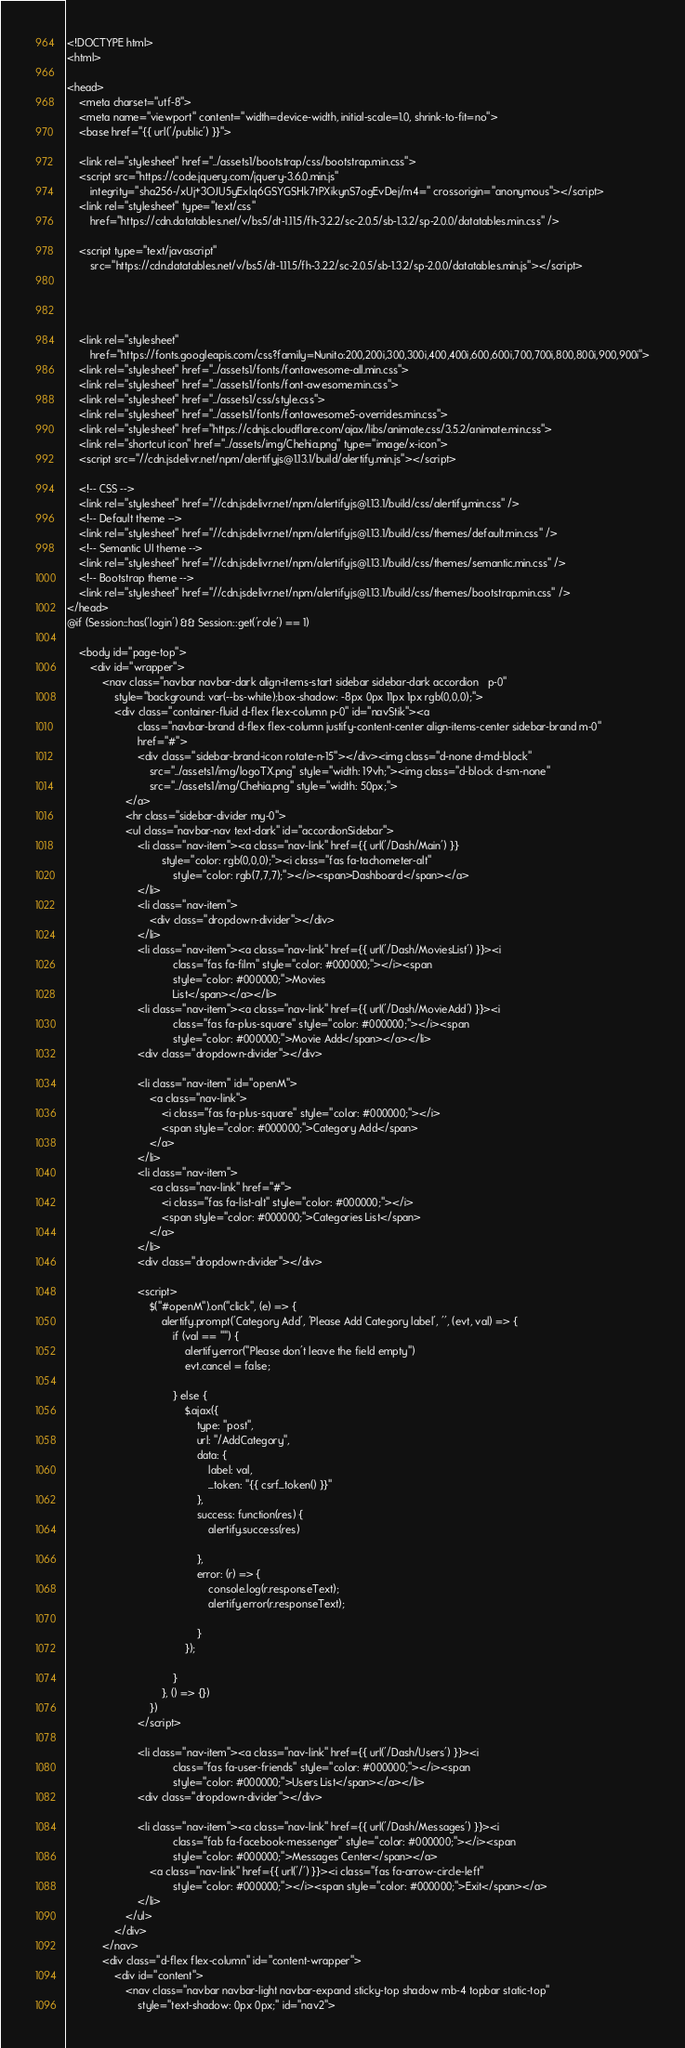Convert code to text. <code><loc_0><loc_0><loc_500><loc_500><_PHP_><!DOCTYPE html>
<html>

<head>
    <meta charset="utf-8">
    <meta name="viewport" content="width=device-width, initial-scale=1.0, shrink-to-fit=no">
    <base href="{{ url('/public') }}">

    <link rel="stylesheet" href="../assets1/bootstrap/css/bootstrap.min.css">
    <script src="https://code.jquery.com/jquery-3.6.0.min.js"
        integrity="sha256-/xUj+3OJU5yExlq6GSYGSHk7tPXikynS7ogEvDej/m4=" crossorigin="anonymous"></script>
    <link rel="stylesheet" type="text/css"
        href="https://cdn.datatables.net/v/bs5/dt-1.11.5/fh-3.2.2/sc-2.0.5/sb-1.3.2/sp-2.0.0/datatables.min.css" />

    <script type="text/javascript"
        src="https://cdn.datatables.net/v/bs5/dt-1.11.5/fh-3.2.2/sc-2.0.5/sb-1.3.2/sp-2.0.0/datatables.min.js"></script>




    <link rel="stylesheet"
        href="https://fonts.googleapis.com/css?family=Nunito:200,200i,300,300i,400,400i,600,600i,700,700i,800,800i,900,900i">
    <link rel="stylesheet" href="../assets1/fonts/fontawesome-all.min.css">
    <link rel="stylesheet" href="../assets1/fonts/font-awesome.min.css">
    <link rel="stylesheet" href="../assets1/css/style.css">
    <link rel="stylesheet" href="../assets1/fonts/fontawesome5-overrides.min.css">
    <link rel="stylesheet" href="https://cdnjs.cloudflare.com/ajax/libs/animate.css/3.5.2/animate.min.css">
    <link rel="shortcut icon" href="../assets/img/Chehia.png" type="image/x-icon">
    <script src="//cdn.jsdelivr.net/npm/alertifyjs@1.13.1/build/alertify.min.js"></script>

    <!-- CSS -->
    <link rel="stylesheet" href="//cdn.jsdelivr.net/npm/alertifyjs@1.13.1/build/css/alertify.min.css" />
    <!-- Default theme -->
    <link rel="stylesheet" href="//cdn.jsdelivr.net/npm/alertifyjs@1.13.1/build/css/themes/default.min.css" />
    <!-- Semantic UI theme -->
    <link rel="stylesheet" href="//cdn.jsdelivr.net/npm/alertifyjs@1.13.1/build/css/themes/semantic.min.css" />
    <!-- Bootstrap theme -->
    <link rel="stylesheet" href="//cdn.jsdelivr.net/npm/alertifyjs@1.13.1/build/css/themes/bootstrap.min.css" />
</head>
@if (Session::has('login') && Session::get('role') == 1)

    <body id="page-top">
        <div id="wrapper">
            <nav class="navbar navbar-dark align-items-start sidebar sidebar-dark accordion   p-0"
                style="background: var(--bs-white);box-shadow: -8px 0px 11px 1px rgb(0,0,0);">
                <div class="container-fluid d-flex flex-column p-0" id="navStik"><a
                        class="navbar-brand d-flex flex-column justify-content-center align-items-center sidebar-brand m-0"
                        href="#">
                        <div class="sidebar-brand-icon rotate-n-15"></div><img class="d-none d-md-block"
                            src="../assets1/img/logoTX.png" style="width: 19vh;"><img class="d-block d-sm-none"
                            src="../assets1/img/Chehia.png" style="width: 50px;">
                    </a>
                    <hr class="sidebar-divider my-0">
                    <ul class="navbar-nav text-dark" id="accordionSidebar">
                        <li class="nav-item"><a class="nav-link" href={{ url('/Dash/Main') }}
                                style="color: rgb(0,0,0);"><i class="fas fa-tachometer-alt"
                                    style="color: rgb(7,7,7);"></i><span>Dashboard</span></a>
                        </li>
                        <li class="nav-item">
                            <div class="dropdown-divider"></div>
                        </li>
                        <li class="nav-item"><a class="nav-link" href={{ url('/Dash/MoviesList') }}><i
                                    class="fas fa-film" style="color: #000000;"></i><span
                                    style="color: #000000;">Movies
                                    List</span></a></li>
                        <li class="nav-item"><a class="nav-link" href={{ url('/Dash/MovieAdd') }}><i
                                    class="fas fa-plus-square" style="color: #000000;"></i><span
                                    style="color: #000000;">Movie Add</span></a></li>
                        <div class="dropdown-divider"></div>

                        <li class="nav-item" id="openM">
                            <a class="nav-link">
                                <i class="fas fa-plus-square" style="color: #000000;"></i>
                                <span style="color: #000000;">Category Add</span>
                            </a>
                        </li>
                        <li class="nav-item">
                            <a class="nav-link" href="#">
                                <i class="fas fa-list-alt" style="color: #000000;"></i>
                                <span style="color: #000000;">Categories List</span>
                            </a>
                        </li>
                        <div class="dropdown-divider"></div>

                        <script>
                            $("#openM").on("click", (e) => {
                                alertify.prompt('Category Add', 'Please Add Category label', '', (evt, val) => {
                                    if (val == "") {
                                        alertify.error("Please don't leave the field empty")
                                        evt.cancel = false;

                                    } else {
                                        $.ajax({
                                            type: "post",
                                            url: "/AddCategory",
                                            data: {
                                                label: val,
                                                _token: "{{ csrf_token() }}"
                                            },
                                            success: function(res) {
                                                alertify.success(res)

                                            },
                                            error: (r) => {
                                                console.log(r.responseText);
                                                alertify.error(r.responseText);

                                            }
                                        });

                                    }
                                }, () => {})
                            })
                        </script>

                        <li class="nav-item"><a class="nav-link" href={{ url('/Dash/Users') }}><i
                                    class="fas fa-user-friends" style="color: #000000;"></i><span
                                    style="color: #000000;">Users List</span></a></li>
                        <div class="dropdown-divider"></div>

                        <li class="nav-item"><a class="nav-link" href={{ url('/Dash/Messages') }}><i
                                    class="fab fa-facebook-messenger" style="color: #000000;"></i><span
                                    style="color: #000000;">Messages Center</span></a>
                            <a class="nav-link" href={{ url('/') }}><i class="fas fa-arrow-circle-left"
                                    style="color: #000000;"></i><span style="color: #000000;">Exit</span></a>
                        </li>
                    </ul>
                </div>
            </nav>
            <div class="d-flex flex-column" id="content-wrapper">
                <div id="content">
                    <nav class="navbar navbar-light navbar-expand sticky-top shadow mb-4 topbar static-top"
                        style="text-shadow: 0px 0px;" id="nav2"></code> 